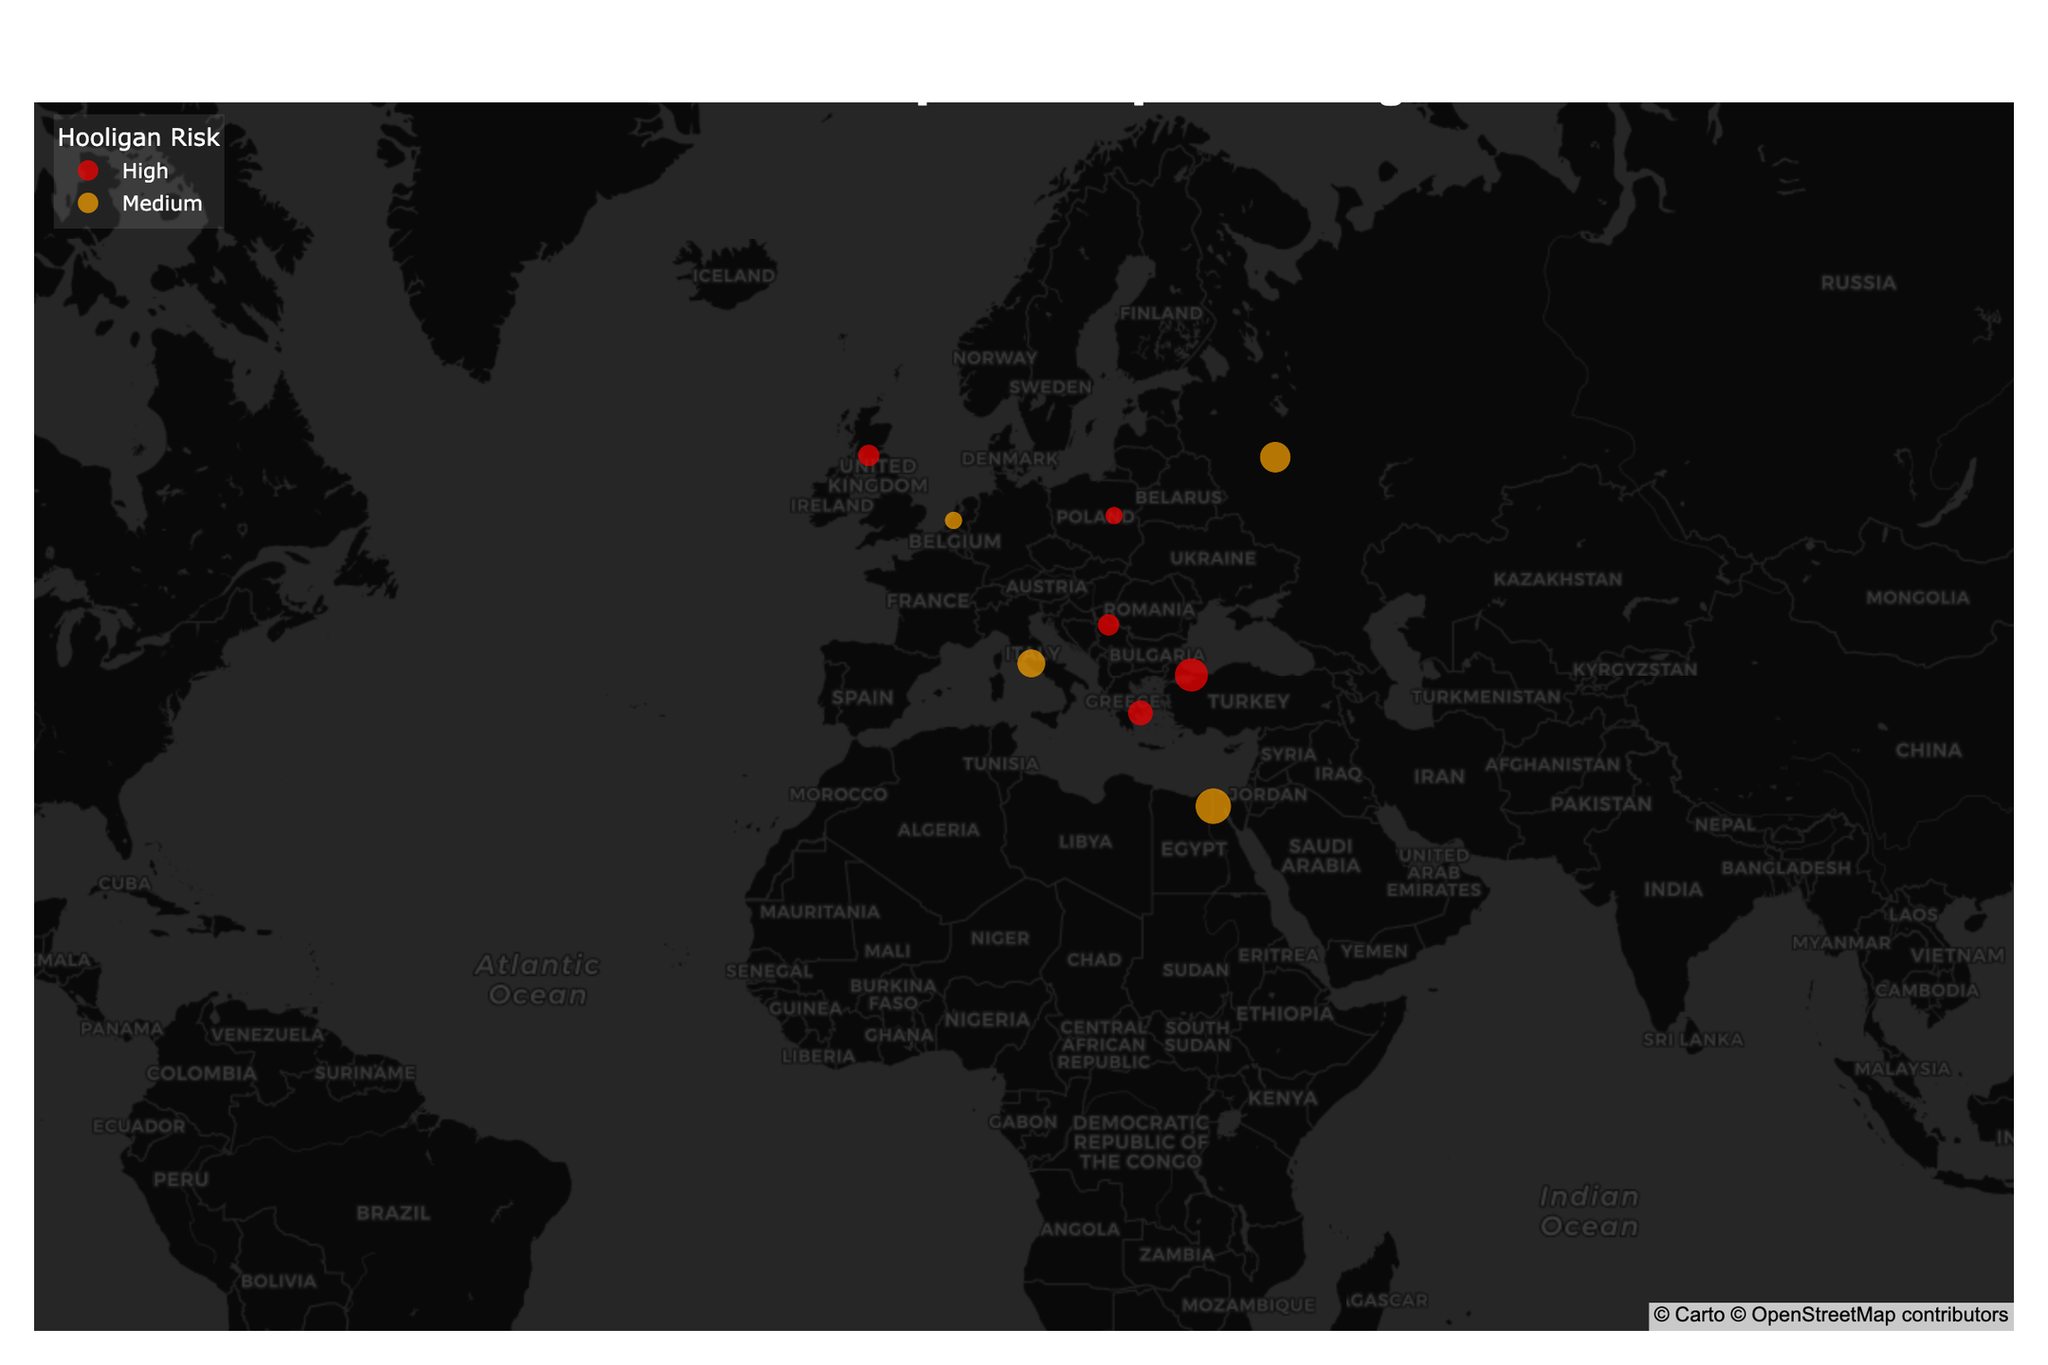what is the title of the map? The title of the map is located at the top center of the figure in bold. It reads "International Hotspots for Sports Hooliganism"
Answer: International Hotspots for Sports Hooliganism which cities are marked with a high hooligan risk? To identify cities with a high hooligan risk, look for points colored in red. The cities with red markers are Belgrade, Istanbul, Warsaw, Glasgow, and Athens.
Answer: Belgrade, Istanbul, Warsaw, Glasgow, Athens how far is the sports hooliganism hotspot from the city center in Cairo? To determine the distance from the city center, hover over the point representing Cairo. The hover data includes the "Distance to City Center" information, which is listed as 8 km.
Answer: 8 km which city has the highest distance to the city center among the marked hooliganism hotspots? By comparing all the distances to city center values, the maximum value is observed for Cairo with 8 km.
Answer: Cairo compare the hooligan risk level between Buenos Aires and Rotterdam Identify the risk levels by looking at the colors of the markers for Buenos Aires and Rotterdam. Both are colored in orange, indicating a medium risk level.
Answer: Both have medium risk what is the primary sport associated with hooliganism in Rome? Hover over the point representing Rome to see the hover data, which includes the "Major Sports" information. For Rome, it is football.
Answer: Football how many cities have a medium hooligan risk? Count the number of orange markers on the map. The cities with a medium risk are Rome, Buenos Aires, Moscow, Cairo, and Rotterdam, making a total of five.
Answer: 5 what is the latitude and longitude of Istanbul? Hover over the point representing Istanbul to reveal the latitude and longitude information. It shows 41.0082 and 28.9784, respectively.
Answer: 41.0082, 28.9784 which city has a lower distance to the city center from a hooliganism hotspot: Belgrade or Warsaw? Compare the "Distance to City Center" for Belgrade and Warsaw by hovering over each point. Belgrade has a distance of 3 km, and Warsaw has a distance of 2 km. Therefore, Warsaw has a lower distance.
Answer: Warsaw what is the commonality in the major sports associated with hooliganism in the listed cities? Hover over each point and observe the "Major Sports" information. The common sport for hooliganism in almost all the cities is football. Moscow is an exception with football and ice hockey.
Answer: Football 